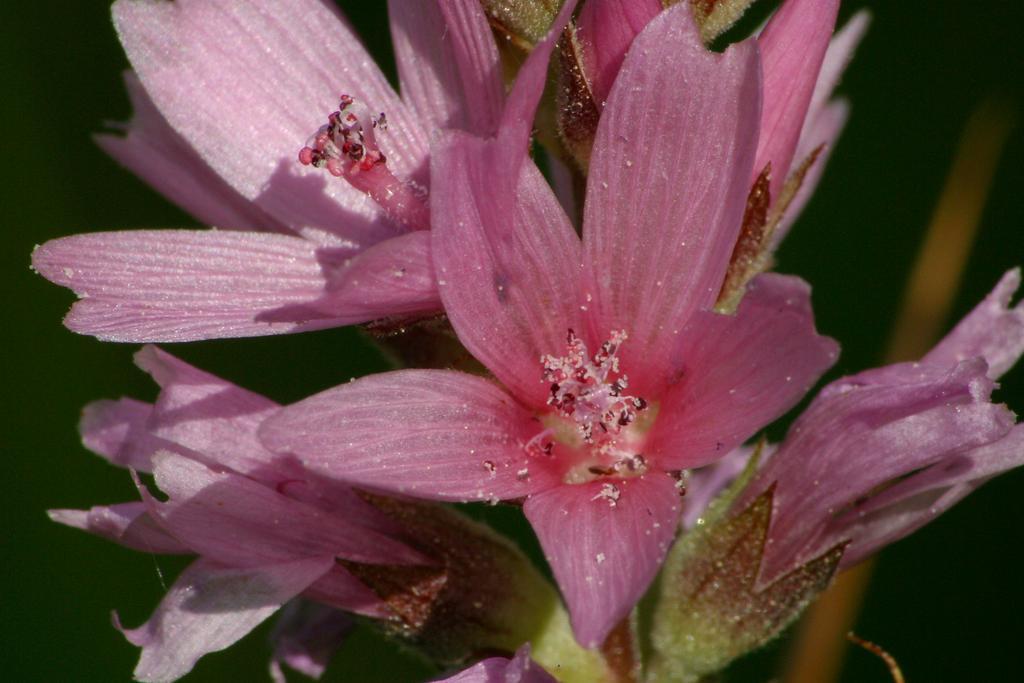In one or two sentences, can you explain what this image depicts? In the foreground of this image, there are pink flowers have pollen grains in the middle of the flower. In the background, there is a plant. 